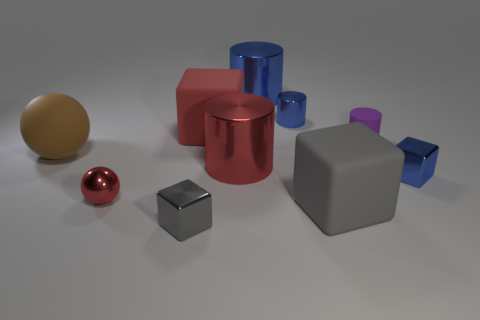Subtract all blue cylinders. How many cylinders are left? 2 Subtract all red cubes. How many cubes are left? 3 Subtract 0 cyan spheres. How many objects are left? 10 Subtract all cylinders. How many objects are left? 6 Subtract 1 balls. How many balls are left? 1 Subtract all red blocks. Subtract all blue cylinders. How many blocks are left? 3 Subtract all gray cubes. How many yellow balls are left? 0 Subtract all rubber balls. Subtract all red rubber things. How many objects are left? 8 Add 7 blue cylinders. How many blue cylinders are left? 9 Add 9 big red metal cylinders. How many big red metal cylinders exist? 10 